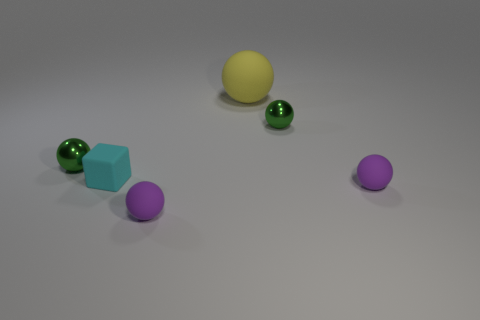There is a big thing; does it have the same shape as the tiny purple thing that is to the right of the yellow matte ball?
Your response must be concise. Yes. How many tiny metallic spheres are both left of the matte block and right of the yellow rubber object?
Make the answer very short. 0. There is a metal ball that is behind the green shiny ball that is on the left side of the cyan rubber block; what size is it?
Make the answer very short. Small. Are there any tiny metallic balls?
Provide a short and direct response. Yes. The thing that is right of the yellow matte object and in front of the small cube is made of what material?
Give a very brief answer. Rubber. Is the number of small green metal objects that are to the left of the tiny cube greater than the number of large balls that are behind the large matte object?
Your response must be concise. Yes. Are there any brown things that have the same size as the cyan object?
Give a very brief answer. No. What is the size of the purple ball that is right of the small green shiny ball that is on the right side of the green sphere that is to the left of the small cyan block?
Provide a short and direct response. Small. The matte block has what color?
Ensure brevity in your answer.  Cyan. Are there more green balls that are behind the cube than small gray cylinders?
Offer a terse response. Yes. 